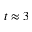<formula> <loc_0><loc_0><loc_500><loc_500>t \approx 3</formula> 